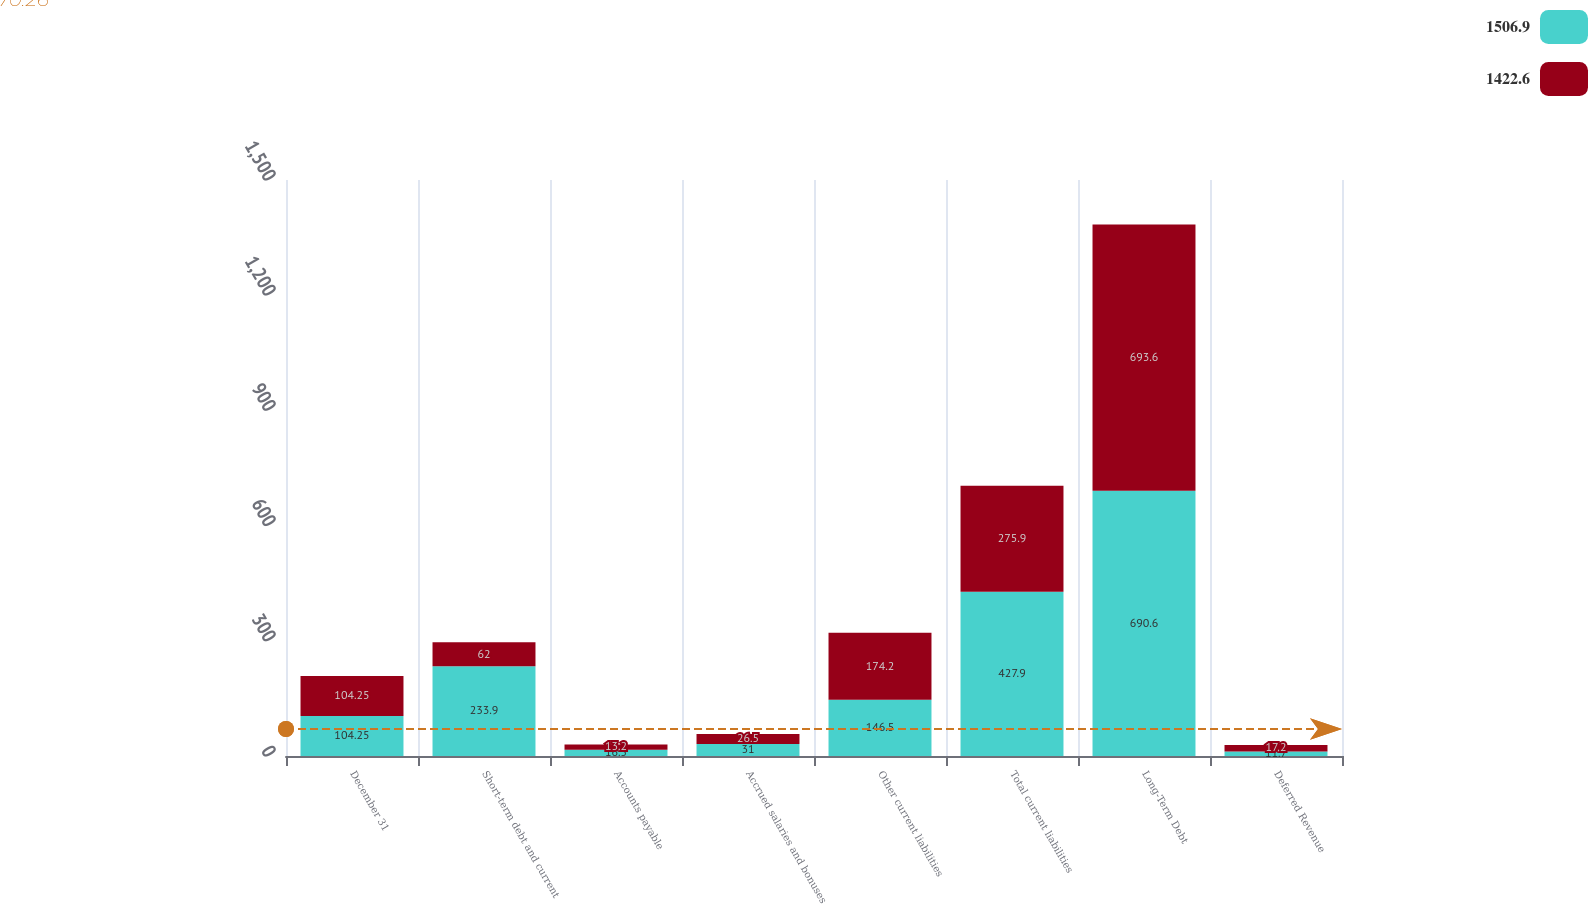<chart> <loc_0><loc_0><loc_500><loc_500><stacked_bar_chart><ecel><fcel>December 31<fcel>Short-term debt and current<fcel>Accounts payable<fcel>Accrued salaries and bonuses<fcel>Other current liabilities<fcel>Total current liabilities<fcel>Long-Term Debt<fcel>Deferred Revenue<nl><fcel>1506.9<fcel>104.25<fcel>233.9<fcel>16.5<fcel>31<fcel>146.5<fcel>427.9<fcel>690.6<fcel>11.7<nl><fcel>1422.6<fcel>104.25<fcel>62<fcel>13.2<fcel>26.5<fcel>174.2<fcel>275.9<fcel>693.6<fcel>17.2<nl></chart> 